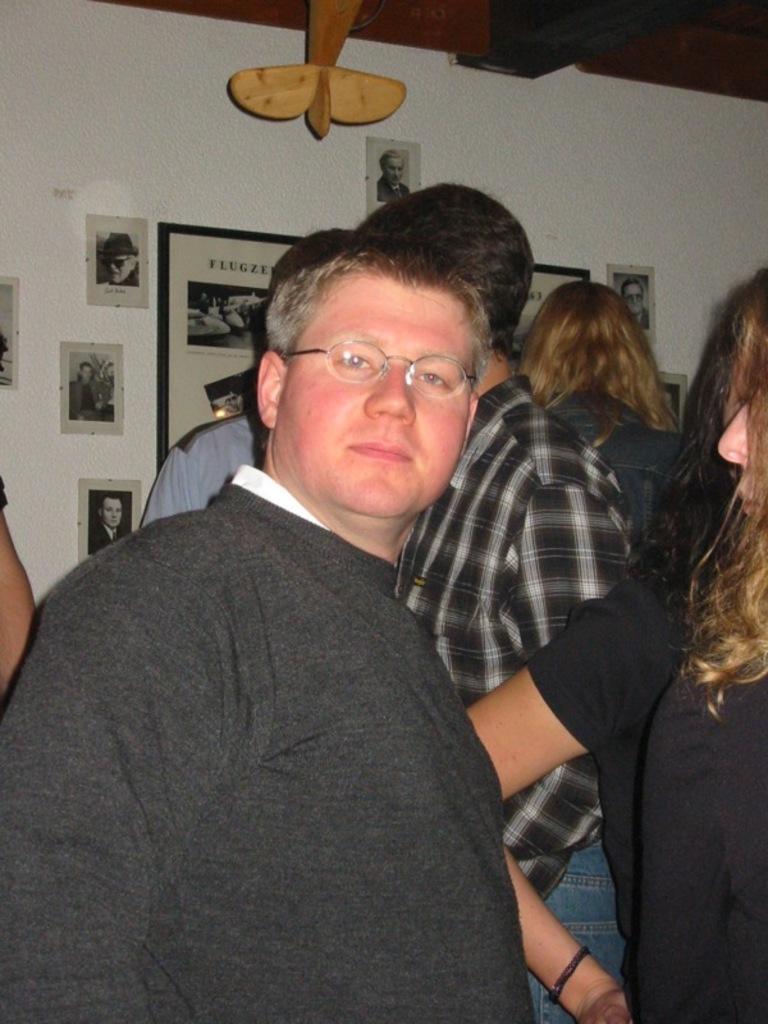Can you describe this image briefly? In this image in the front there is a man standing and in the center there are persons. In the background there are posters on the wall with some text and images on it. 